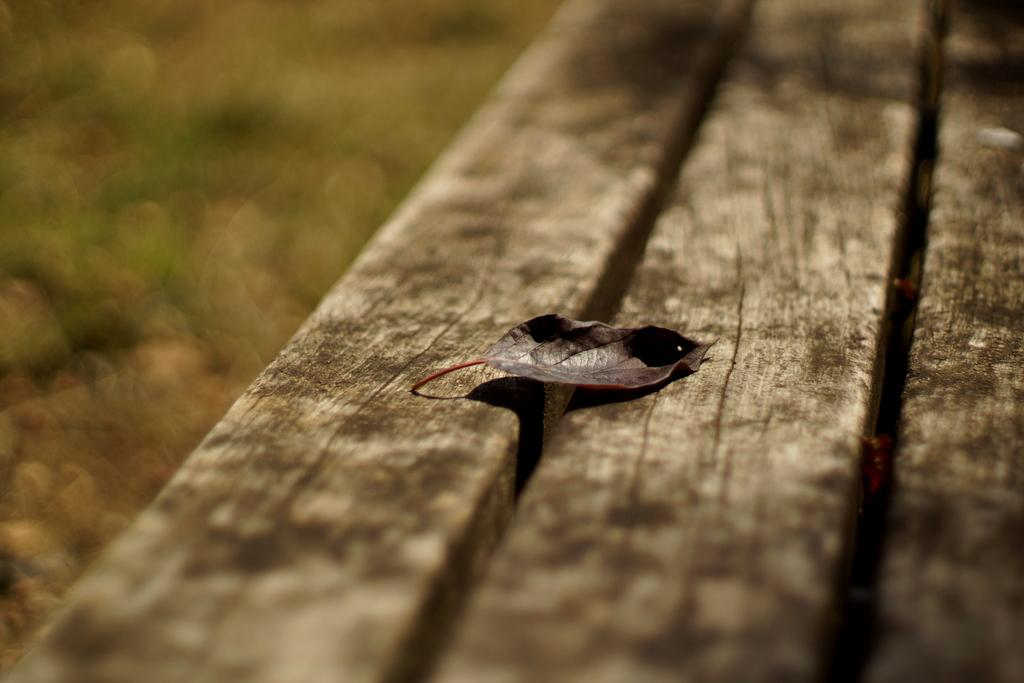What is present on the wooden surface in the image? There is a leaf on the wooden surface in the image. Can you describe the wooden surface in the image? The wooden surface is not described in the provided facts, but it is mentioned that the leaf is on a wooden surface. What type of hole can be seen in the leaf in the image? There is no hole present in the leaf in the image. Can you describe the camera used to take the image? The provided facts do not mention a camera or any details about the image-taking process. 